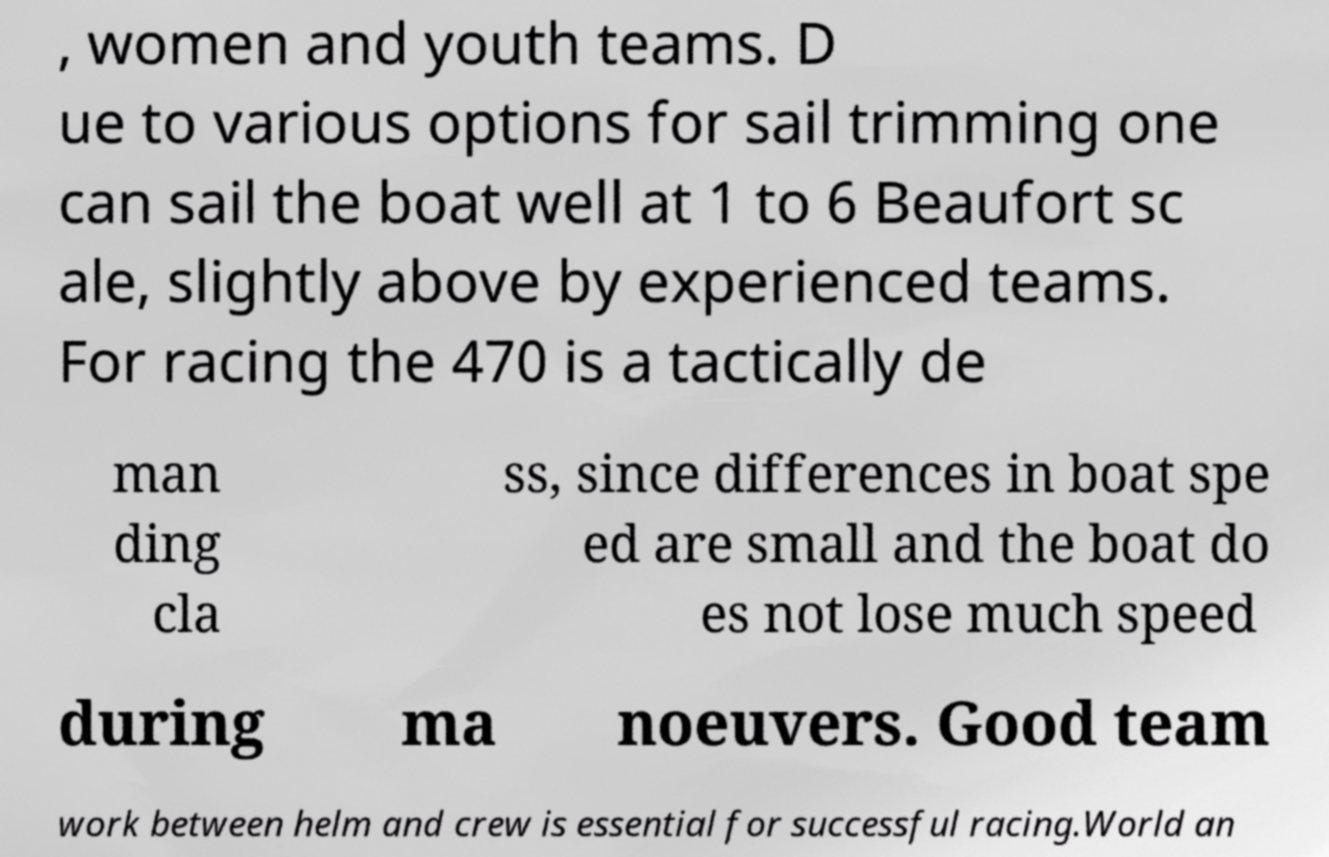Could you assist in decoding the text presented in this image and type it out clearly? , women and youth teams. D ue to various options for sail trimming one can sail the boat well at 1 to 6 Beaufort sc ale, slightly above by experienced teams. For racing the 470 is a tactically de man ding cla ss, since differences in boat spe ed are small and the boat do es not lose much speed during ma noeuvers. Good team work between helm and crew is essential for successful racing.World an 